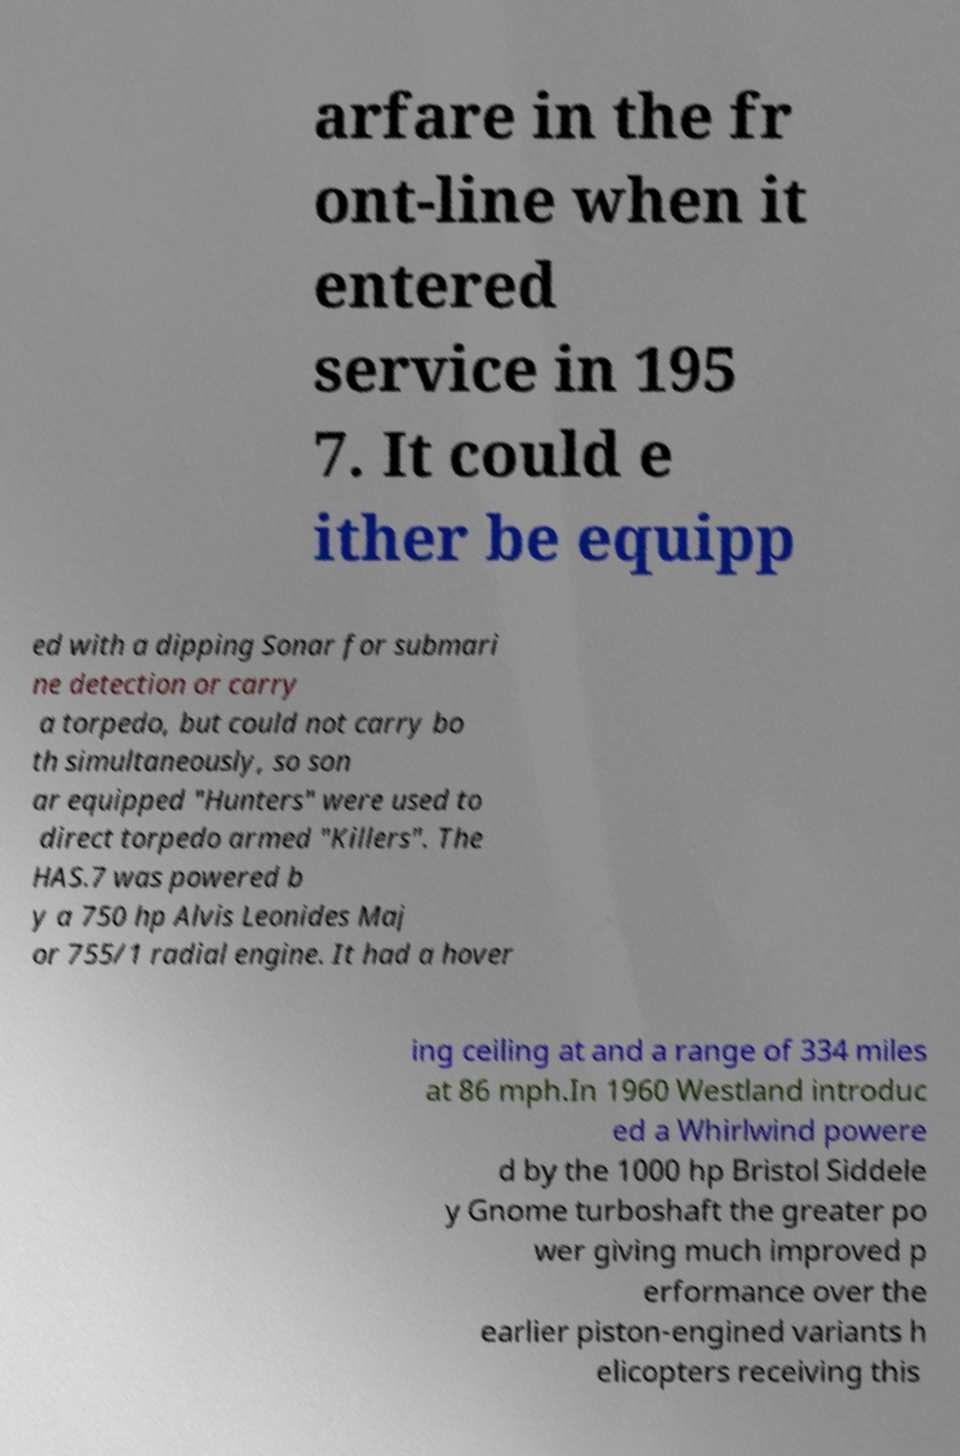Can you accurately transcribe the text from the provided image for me? arfare in the fr ont-line when it entered service in 195 7. It could e ither be equipp ed with a dipping Sonar for submari ne detection or carry a torpedo, but could not carry bo th simultaneously, so son ar equipped "Hunters" were used to direct torpedo armed "Killers". The HAS.7 was powered b y a 750 hp Alvis Leonides Maj or 755/1 radial engine. It had a hover ing ceiling at and a range of 334 miles at 86 mph.In 1960 Westland introduc ed a Whirlwind powere d by the 1000 hp Bristol Siddele y Gnome turboshaft the greater po wer giving much improved p erformance over the earlier piston-engined variants h elicopters receiving this 